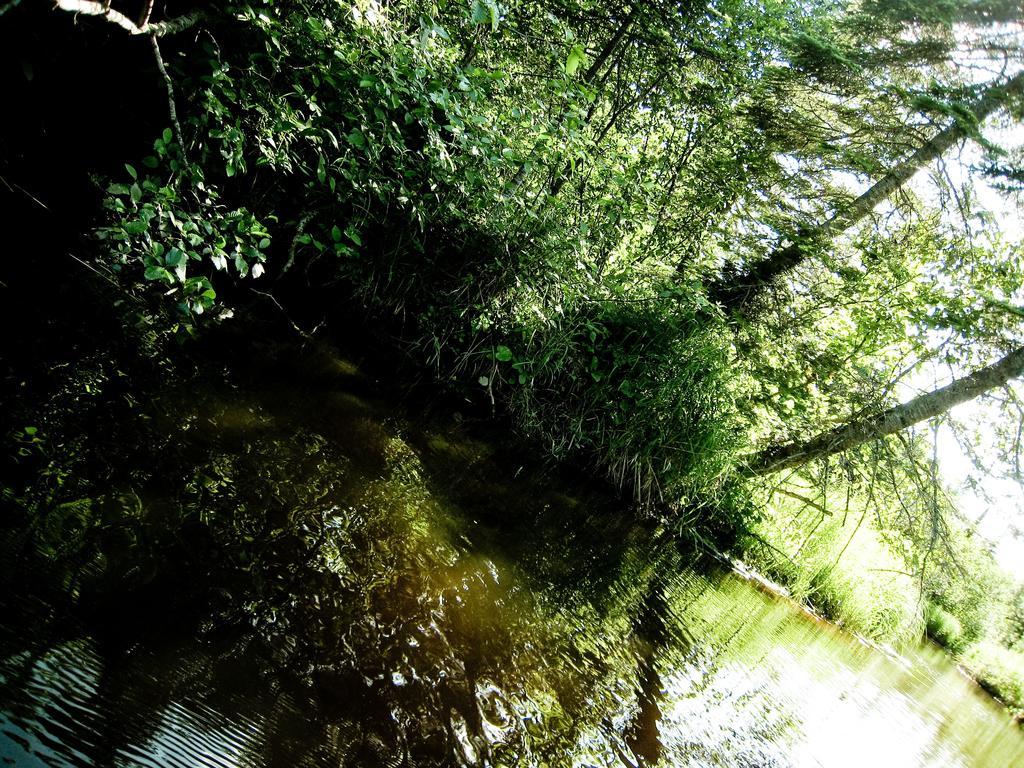How would you summarize this image in a sentence or two? In this image in the front there is water. In the background there are trees. 